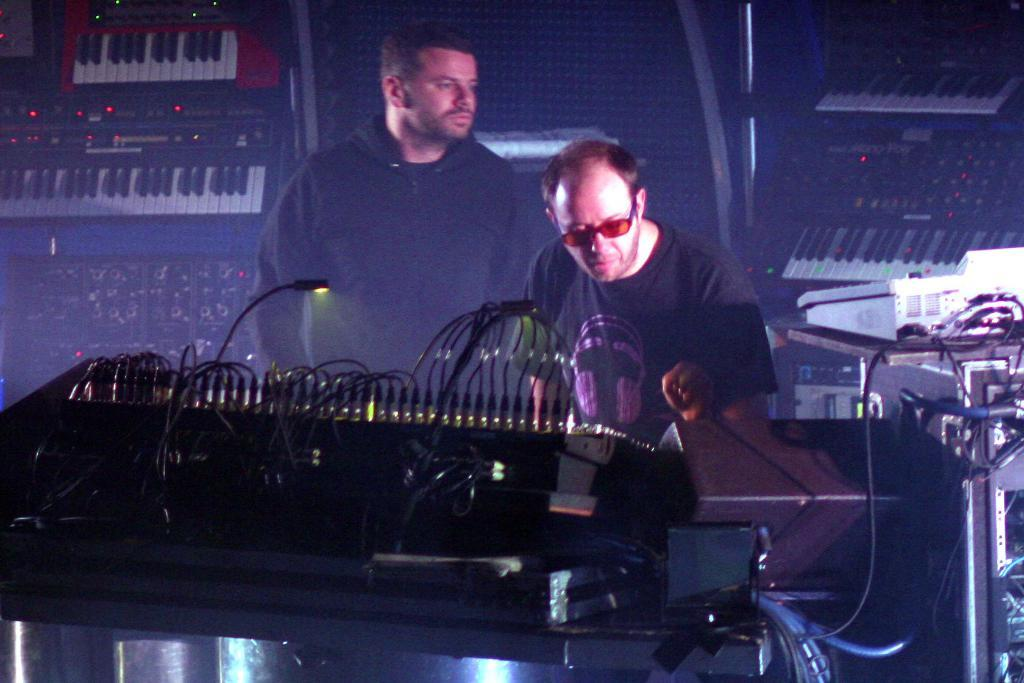How many people are present in the image? There are two people standing on a path in the image. What can be seen in front of the people? There are music systems in front of the people. Are there any visible cables in the image? Yes, there are cables visible in the image. What type of land can be seen in the background of the image? There is no specific type of land visible in the background of the image. Is there any stew being prepared in the image? There is no stew or any cooking activity present in the image. 